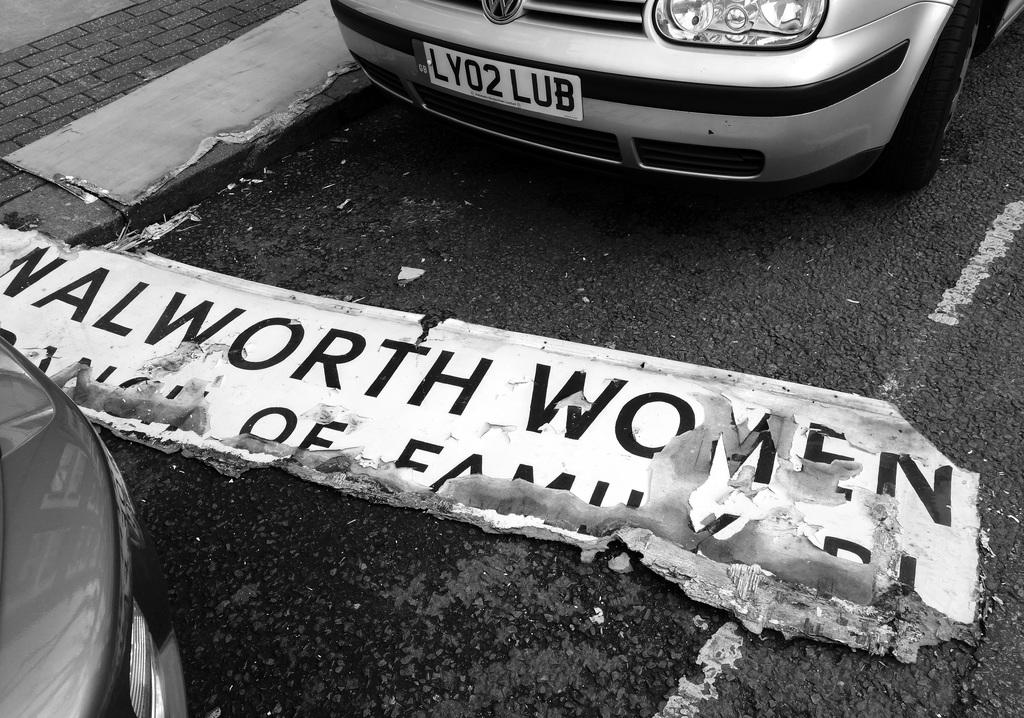What can be seen on the road in the image? There are vehicles on the road in the image. What is the board with text used for in the image? The board with text might be used for displaying information or advertisements. What type of surface is next to the road in the image? There is a pavement next to the road in the image. Where are the scissors located in the image? There are no scissors present in the image. What type of selection is available on the board with text in the image? There is no selection available on the board with text in the image, as it only displays information or advertisements. 